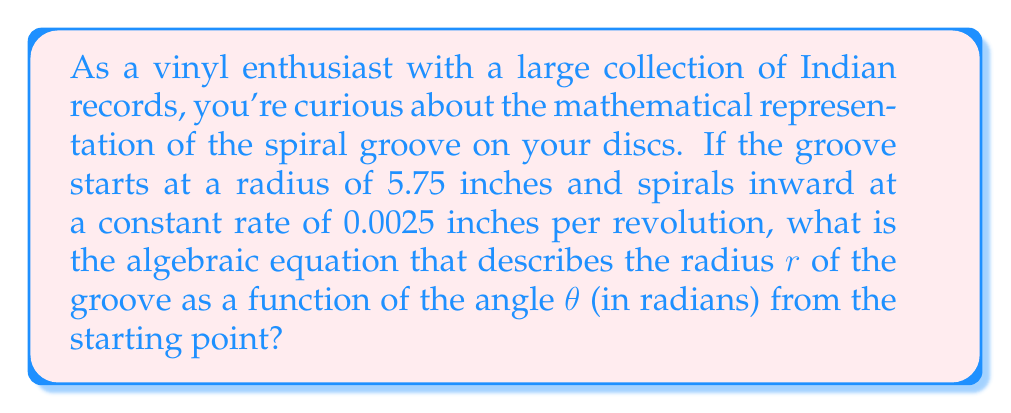Can you solve this math problem? Let's approach this step-by-step:

1) The spiral groove on a vinyl record can be described by an Archimedean spiral. The general equation for an Archimedean spiral is:

   $$ r = a + b\theta $$

   where $r$ is the radius, $\theta$ is the angle in radians, $a$ is the starting radius, and $b$ is the rate at which the spiral moves inward.

2) We're given that the starting radius $a = 5.75$ inches.

3) The rate $b$ is given as 0.0025 inches per revolution. However, we need to convert this to radians:
   
   One revolution = $2\pi$ radians
   
   So, $b = -\frac{0.0025}{2\pi}$ inches/radian (negative because the spiral moves inward)

4) Substituting these values into our equation:

   $$ r = 5.75 - \frac{0.0025}{2\pi}\theta $$

5) To simplify, let's calculate the fraction:

   $$ \frac{0.0025}{2\pi} \approx 0.000397887 $$

6) Our final equation is:

   $$ r = 5.75 - 0.000397887\theta $$

This equation describes the radius of the groove at any given angle $\theta$ from the starting point.
Answer: $r = 5.75 - 0.000397887\theta$ 